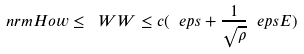<formula> <loc_0><loc_0><loc_500><loc_500>\ n r m H o { w } \leq \ W W \leq c ( \ e p s + \frac { 1 } { \sqrt { \rho } } \ e p s E )</formula> 